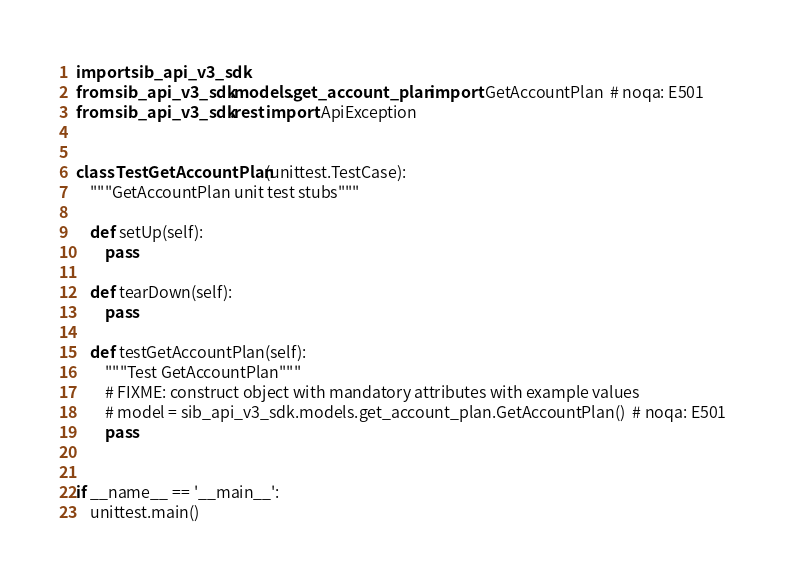Convert code to text. <code><loc_0><loc_0><loc_500><loc_500><_Python_>import sib_api_v3_sdk
from sib_api_v3_sdk.models.get_account_plan import GetAccountPlan  # noqa: E501
from sib_api_v3_sdk.rest import ApiException


class TestGetAccountPlan(unittest.TestCase):
    """GetAccountPlan unit test stubs"""

    def setUp(self):
        pass

    def tearDown(self):
        pass

    def testGetAccountPlan(self):
        """Test GetAccountPlan"""
        # FIXME: construct object with mandatory attributes with example values
        # model = sib_api_v3_sdk.models.get_account_plan.GetAccountPlan()  # noqa: E501
        pass


if __name__ == '__main__':
    unittest.main()
</code> 